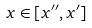Convert formula to latex. <formula><loc_0><loc_0><loc_500><loc_500>x \in [ x ^ { \prime \prime } , x ^ { \prime } ]</formula> 